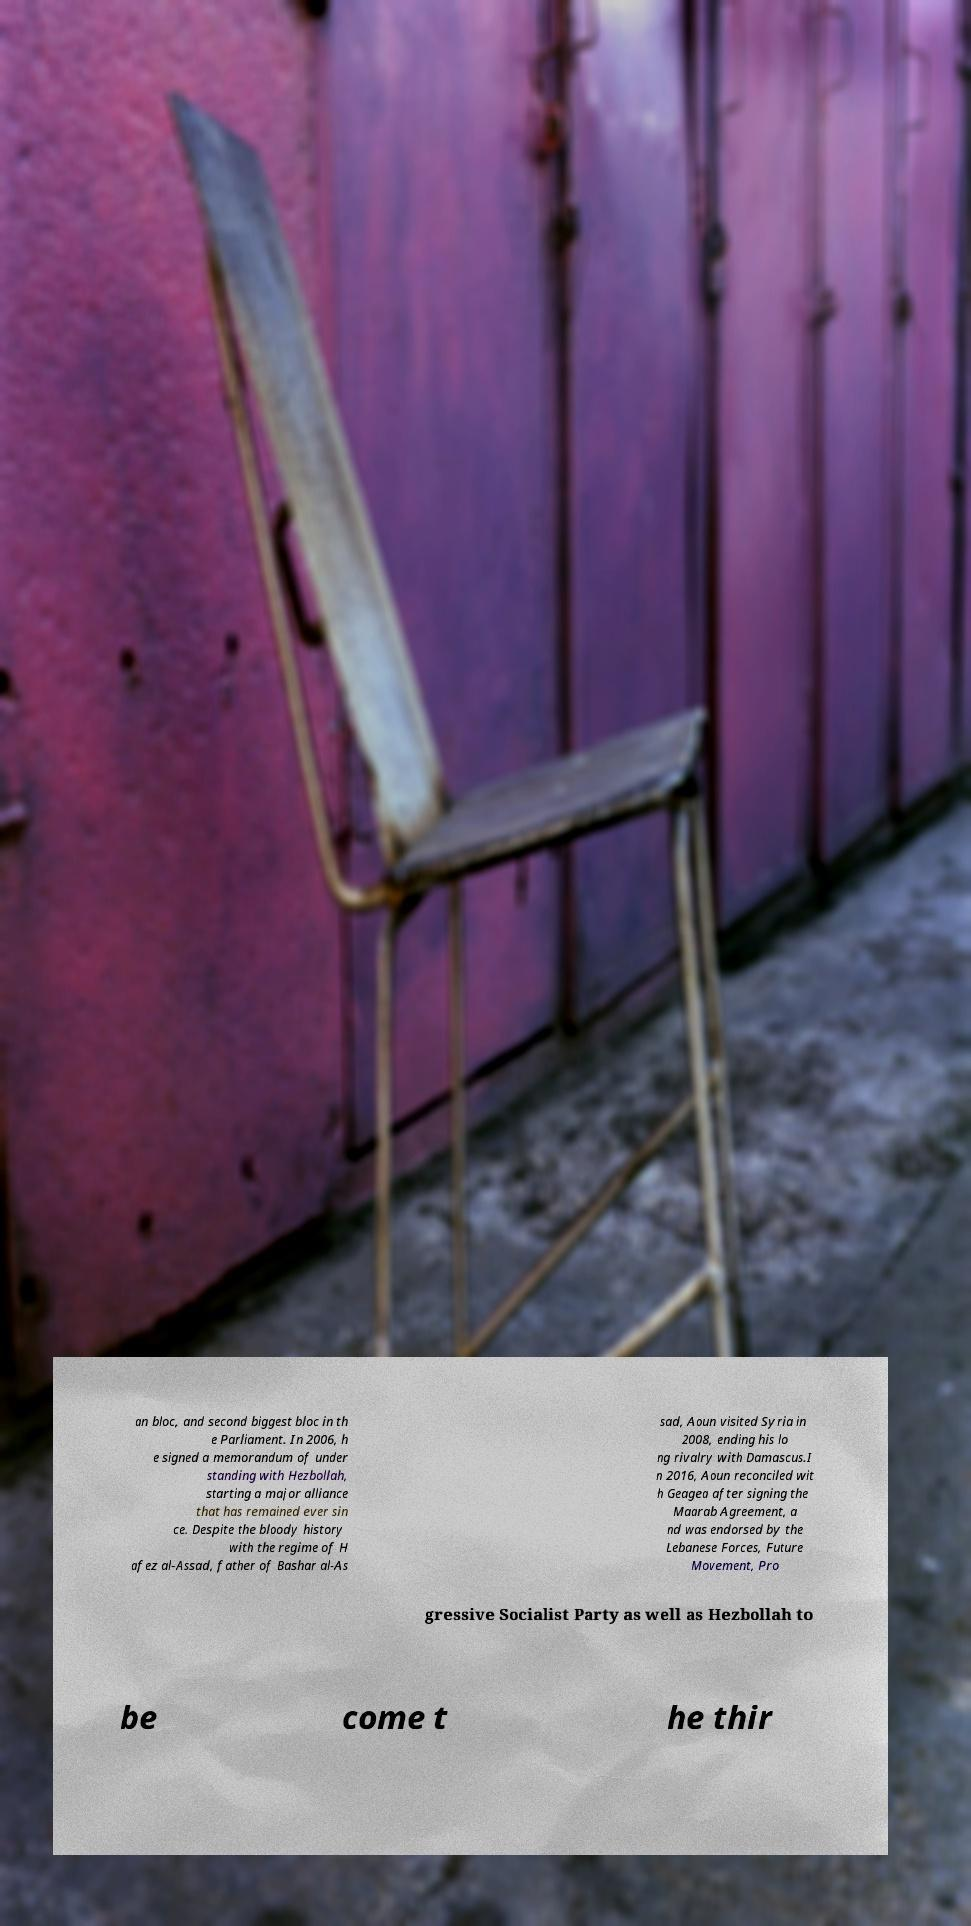Can you accurately transcribe the text from the provided image for me? an bloc, and second biggest bloc in th e Parliament. In 2006, h e signed a memorandum of under standing with Hezbollah, starting a major alliance that has remained ever sin ce. Despite the bloody history with the regime of H afez al-Assad, father of Bashar al-As sad, Aoun visited Syria in 2008, ending his lo ng rivalry with Damascus.I n 2016, Aoun reconciled wit h Geagea after signing the Maarab Agreement, a nd was endorsed by the Lebanese Forces, Future Movement, Pro gressive Socialist Party as well as Hezbollah to be come t he thir 